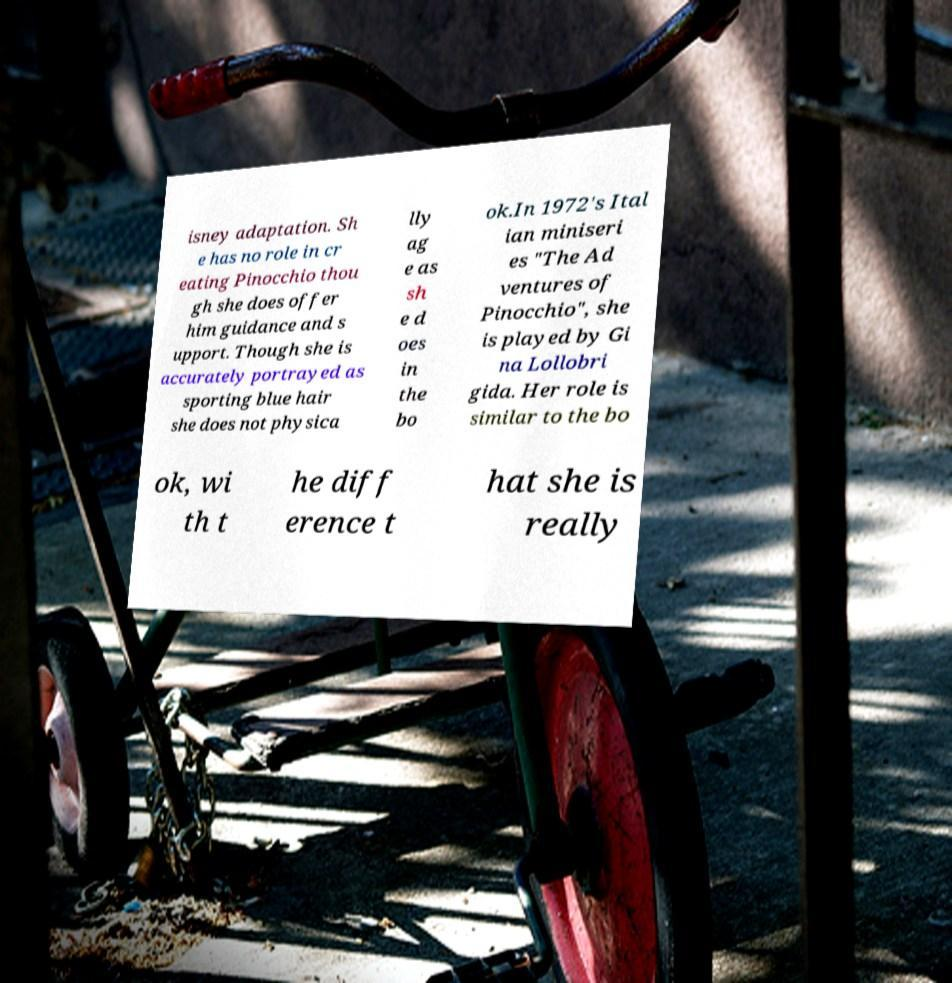There's text embedded in this image that I need extracted. Can you transcribe it verbatim? isney adaptation. Sh e has no role in cr eating Pinocchio thou gh she does offer him guidance and s upport. Though she is accurately portrayed as sporting blue hair she does not physica lly ag e as sh e d oes in the bo ok.In 1972's Ital ian miniseri es "The Ad ventures of Pinocchio", she is played by Gi na Lollobri gida. Her role is similar to the bo ok, wi th t he diff erence t hat she is really 